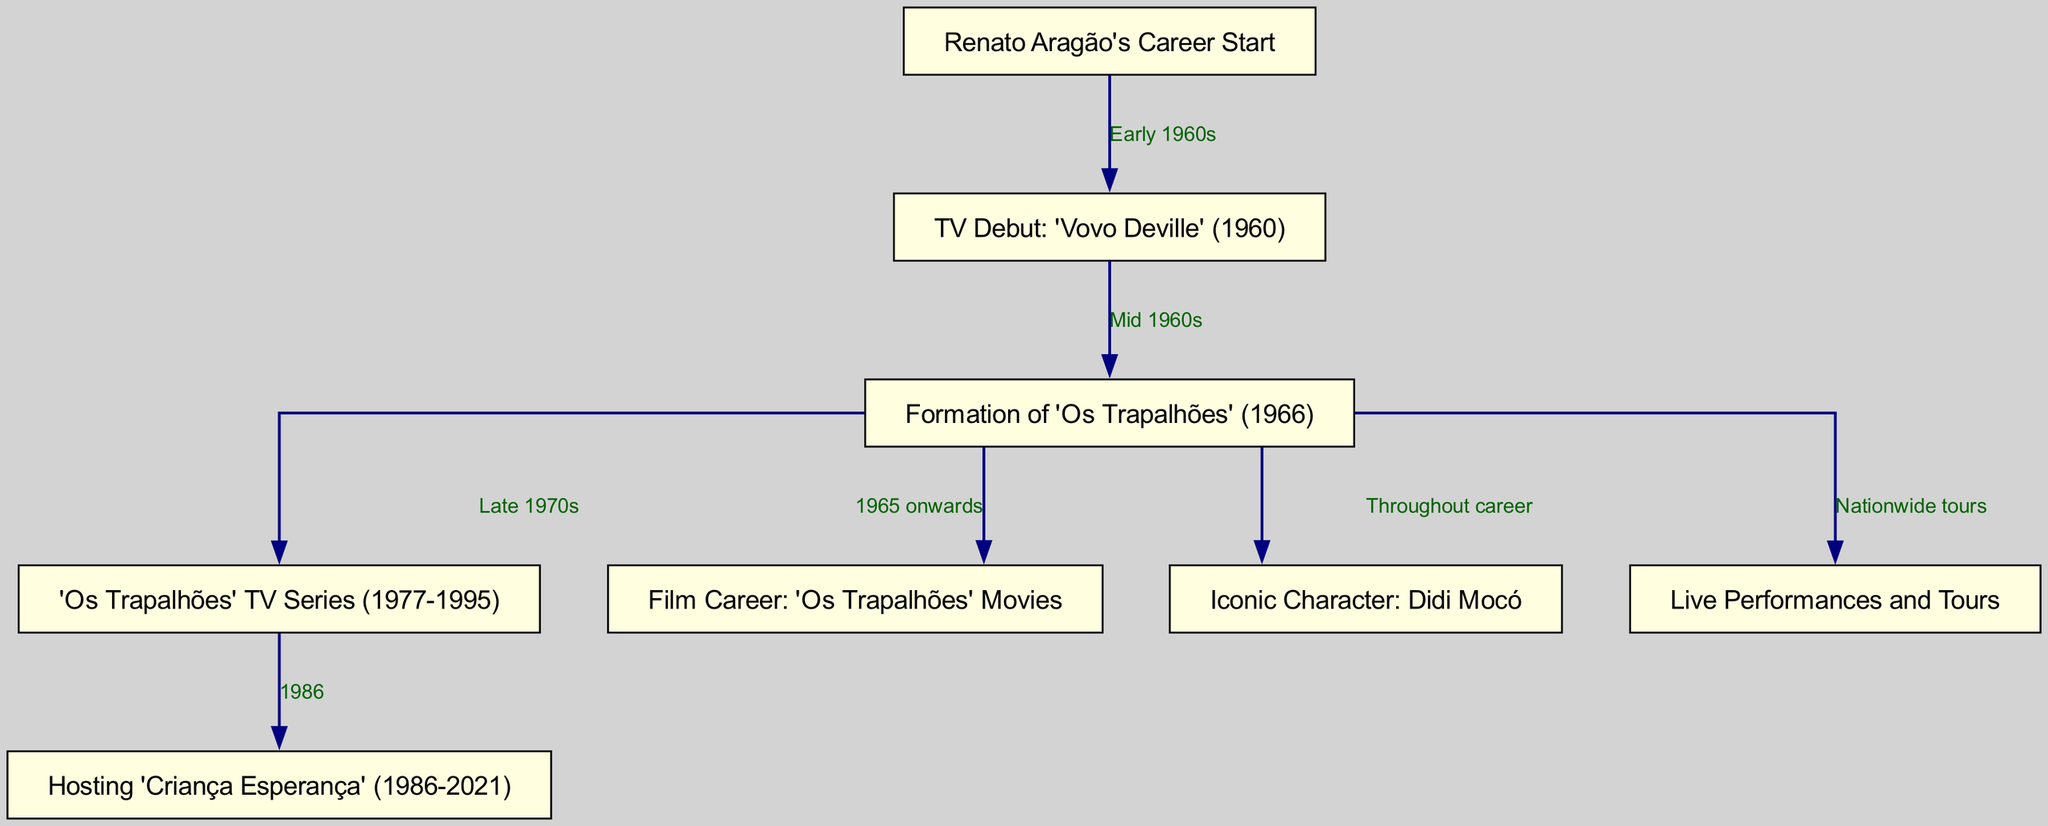What was Renato Aragão's TV debut? The diagram indicates that Renato Aragão's TV debut was "Vovo Deville" in 1960, as shown in the node connected to his career start.
Answer: Vovo Deville In what year did Renato Aragão form 'Os Trapalhões'? The diagram illustrates that 'Os Trapalhões' was formed in 1966, which is connected to his earlier TV debut.
Answer: 1966 What iconic character is associated with Renato Aragão throughout his career? The diagram specifies that the iconic character associated with Renato Aragão throughout his career is "Didi Mocó", directly linked to 'Os Trapalhões'.
Answer: Didi Mocó How many main career phases are depicted in the diagram? The diagram shows several nodes representing major phases in Renato Aragão's career, including TV debut, 'Os Trapalhões', TV series, film career, and live performances, totaling 7 phases.
Answer: 7 What performance initiative did Renato Aragão begin hosting in 1986? According to the diagram, Renato Aragão began hosting "Criança Esperança" in 1986, which connects from the 'Os Trapalhões' TV series node.
Answer: Criança Esperança Which career aspect began in 1977? The diagram highlights that the 'Os Trapalhões' TV series began in 1977, identified as a significant milestone in the progression of his career.
Answer: Os Trapalhões TV Series What was Renato Aragão's primary career focus from 1965 onwards? The diagram indicates that Renato Aragão's primary focus from 1965 onwards has been his film career associated with 'Os Trapalhões' movies.
Answer: Film Career What type of performances did Renato Aragão conduct nationwide? The diagram specifies that Renato Aragão engaged in "Live Performances and Tours," which reflects his nationwide activities connected to 'Os Trapalhões'.
Answer: Live Performances and Tours 